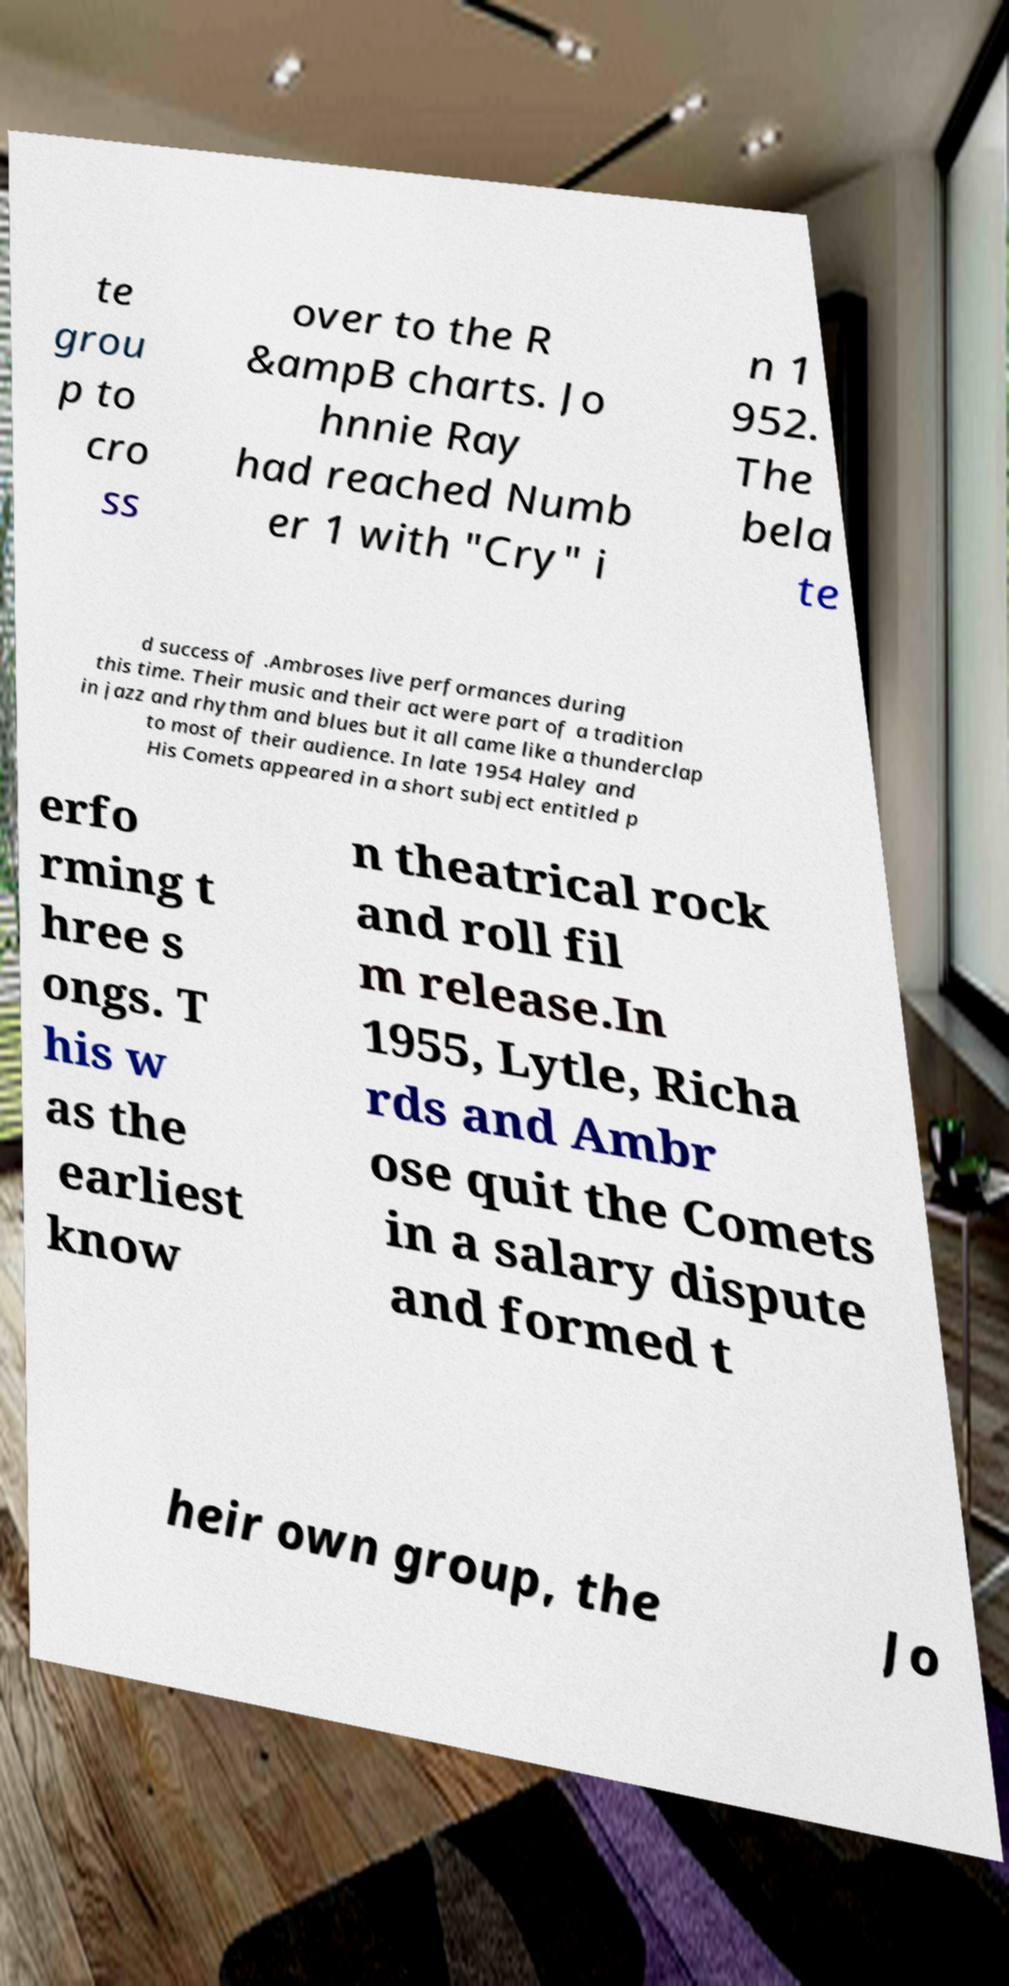Could you assist in decoding the text presented in this image and type it out clearly? te grou p to cro ss over to the R &ampB charts. Jo hnnie Ray had reached Numb er 1 with "Cry" i n 1 952. The bela te d success of .Ambroses live performances during this time. Their music and their act were part of a tradition in jazz and rhythm and blues but it all came like a thunderclap to most of their audience. In late 1954 Haley and His Comets appeared in a short subject entitled p erfo rming t hree s ongs. T his w as the earliest know n theatrical rock and roll fil m release.In 1955, Lytle, Richa rds and Ambr ose quit the Comets in a salary dispute and formed t heir own group, the Jo 